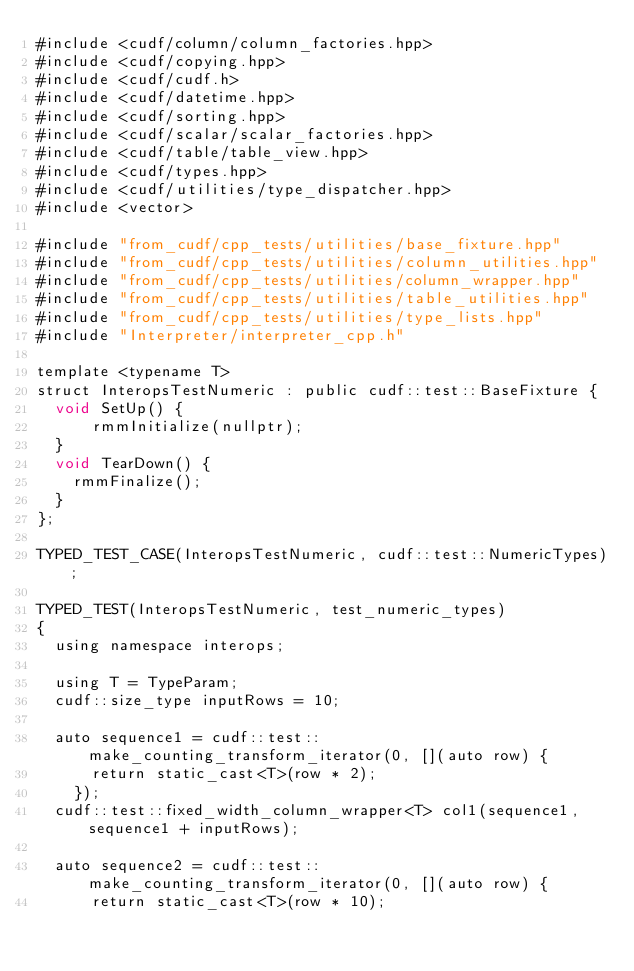Convert code to text. <code><loc_0><loc_0><loc_500><loc_500><_Cuda_>#include <cudf/column/column_factories.hpp>
#include <cudf/copying.hpp>
#include <cudf/cudf.h>
#include <cudf/datetime.hpp>
#include <cudf/sorting.hpp>
#include <cudf/scalar/scalar_factories.hpp>
#include <cudf/table/table_view.hpp>
#include <cudf/types.hpp>
#include <cudf/utilities/type_dispatcher.hpp>
#include <vector>

#include "from_cudf/cpp_tests/utilities/base_fixture.hpp"
#include "from_cudf/cpp_tests/utilities/column_utilities.hpp"
#include "from_cudf/cpp_tests/utilities/column_wrapper.hpp"
#include "from_cudf/cpp_tests/utilities/table_utilities.hpp"
#include "from_cudf/cpp_tests/utilities/type_lists.hpp"
#include "Interpreter/interpreter_cpp.h"

template <typename T>
struct InteropsTestNumeric : public cudf::test::BaseFixture {
  void SetUp() {
	  rmmInitialize(nullptr);
  }
  void TearDown() {
    rmmFinalize();
  }
};

TYPED_TEST_CASE(InteropsTestNumeric, cudf::test::NumericTypes);

TYPED_TEST(InteropsTestNumeric, test_numeric_types)
{
  using namespace interops;

  using T = TypeParam;
  cudf::size_type inputRows = 10;

  auto sequence1 = cudf::test::make_counting_transform_iterator(0, [](auto row) {
      return static_cast<T>(row * 2);
    });
  cudf::test::fixed_width_column_wrapper<T> col1(sequence1, sequence1 + inputRows);

  auto sequence2 = cudf::test::make_counting_transform_iterator(0, [](auto row) {
      return static_cast<T>(row * 10);</code> 